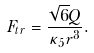<formula> <loc_0><loc_0><loc_500><loc_500>F _ { t r } = \frac { \sqrt { 6 } Q } { \kappa _ { 5 } r ^ { 3 } } .</formula> 